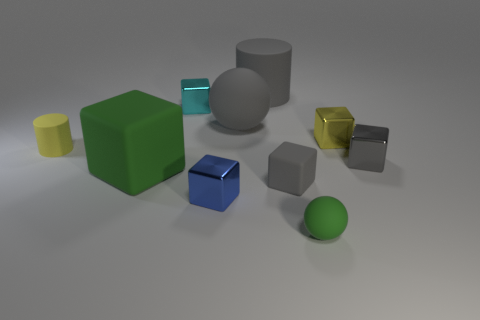Is there anything else that is the same color as the small matte cylinder?
Make the answer very short. Yes. Do the small ball and the big rubber object that is in front of the yellow rubber cylinder have the same color?
Your response must be concise. Yes. Are there any yellow shiny things that have the same shape as the cyan metallic object?
Your answer should be compact. Yes. Is the size of the green rubber thing to the left of the large cylinder the same as the rubber cylinder that is right of the yellow rubber cylinder?
Provide a succinct answer. Yes. Are there more gray matte cylinders than gray rubber things?
Give a very brief answer. No. What number of other yellow cylinders are made of the same material as the small yellow cylinder?
Offer a very short reply. 0. Do the cyan thing and the gray metallic thing have the same shape?
Make the answer very short. Yes. What size is the gray thing on the right side of the rubber sphere that is in front of the big gray object on the left side of the large gray matte cylinder?
Provide a succinct answer. Small. There is a small gray rubber object that is right of the big matte block; is there a yellow thing that is to the right of it?
Offer a very short reply. Yes. How many large green blocks are in front of the sphere in front of the small matte object left of the big rubber cube?
Your answer should be compact. 0. 